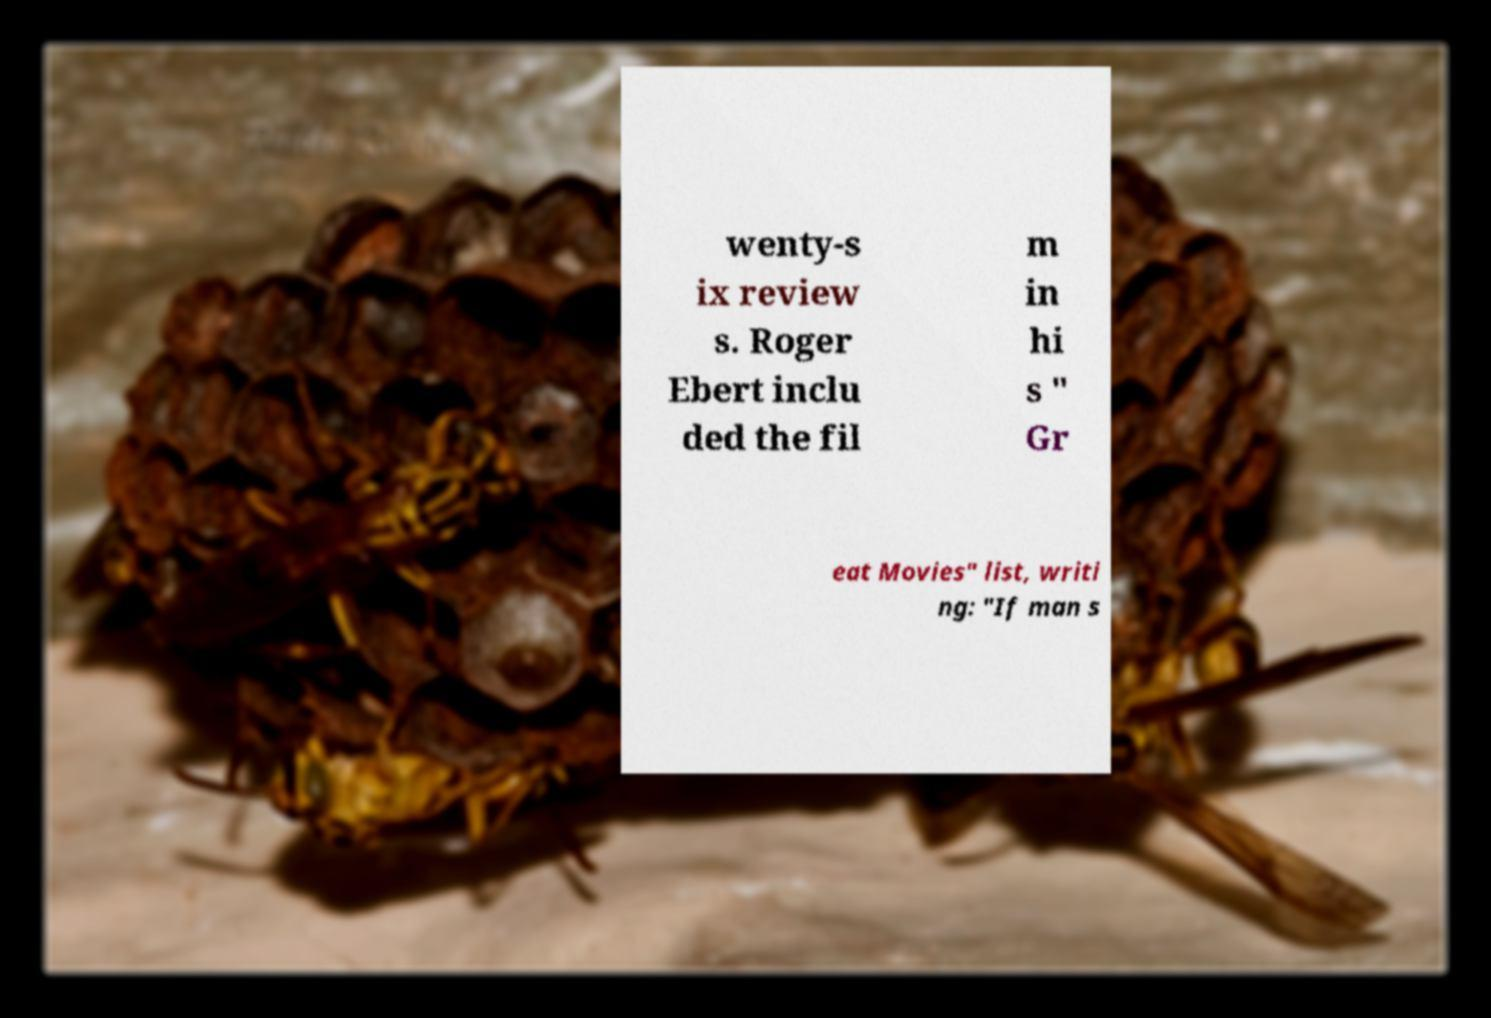Could you assist in decoding the text presented in this image and type it out clearly? wenty-s ix review s. Roger Ebert inclu ded the fil m in hi s " Gr eat Movies" list, writi ng: "If man s 